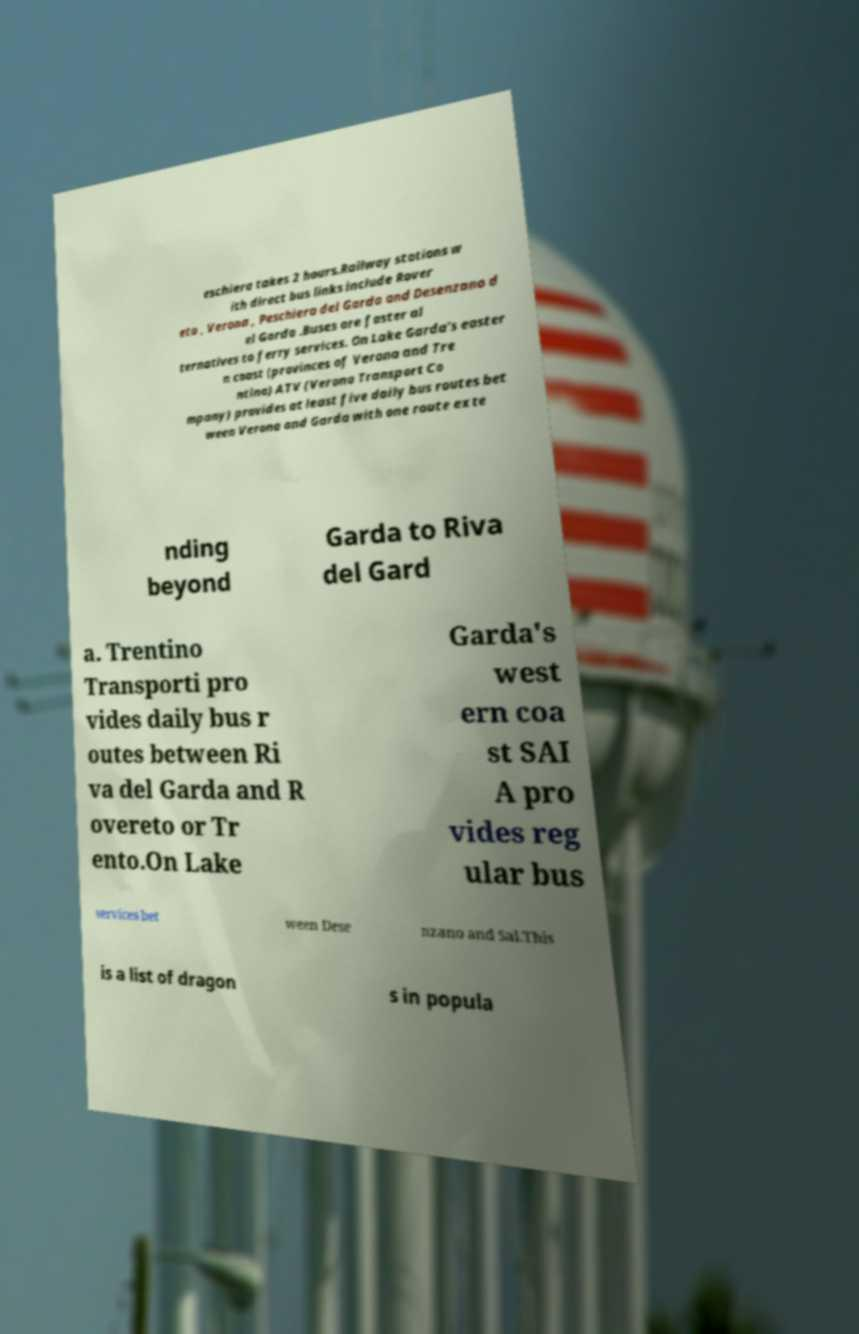Can you accurately transcribe the text from the provided image for me? eschiera takes 2 hours.Railway stations w ith direct bus links include Rover eto , Verona , Peschiera del Garda and Desenzano d el Garda .Buses are faster al ternatives to ferry services. On Lake Garda's easter n coast (provinces of Verona and Tre ntino) ATV (Verona Transport Co mpany) provides at least five daily bus routes bet ween Verona and Garda with one route exte nding beyond Garda to Riva del Gard a. Trentino Transporti pro vides daily bus r outes between Ri va del Garda and R overeto or Tr ento.On Lake Garda's west ern coa st SAI A pro vides reg ular bus services bet ween Dese nzano and Sal.This is a list of dragon s in popula 